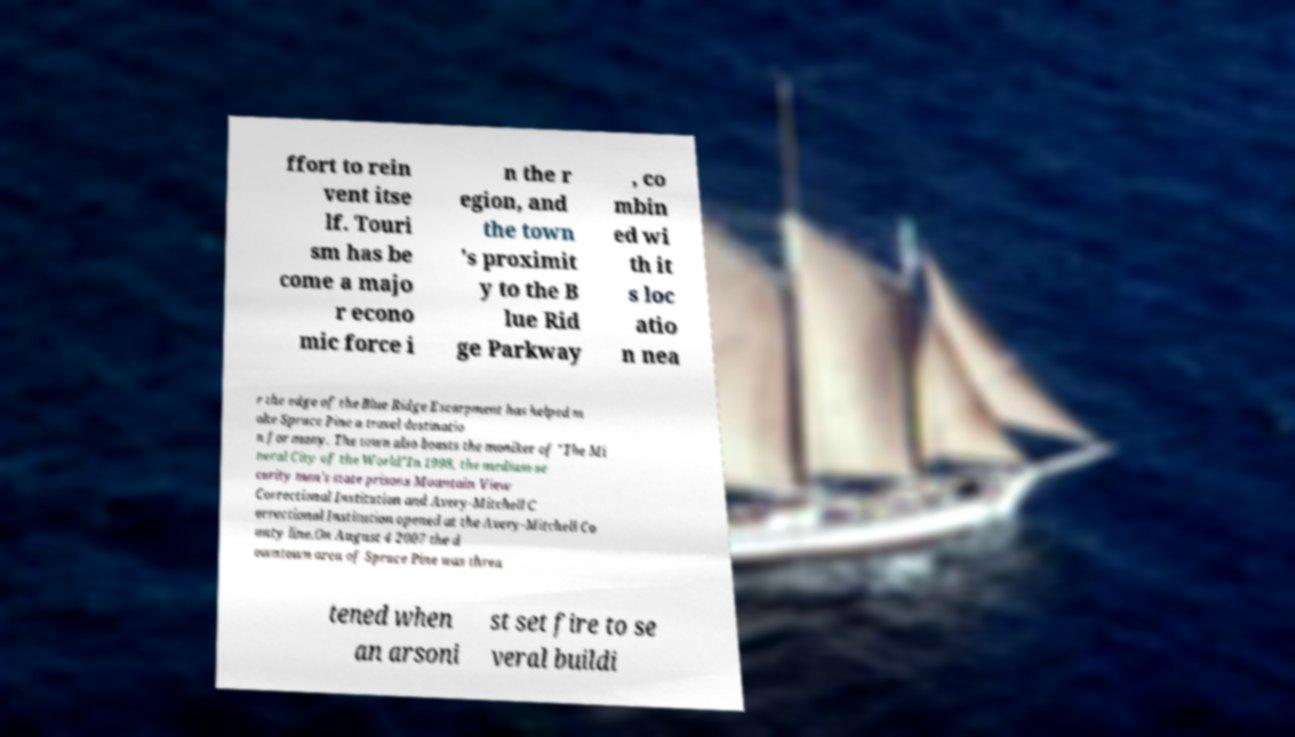Can you accurately transcribe the text from the provided image for me? ffort to rein vent itse lf. Touri sm has be come a majo r econo mic force i n the r egion, and the town 's proximit y to the B lue Rid ge Parkway , co mbin ed wi th it s loc atio n nea r the edge of the Blue Ridge Escarpment has helped m ake Spruce Pine a travel destinatio n for many. The town also boasts the moniker of "The Mi neral City of the World"In 1998, the medium-se curity men's state prisons Mountain View Correctional Institution and Avery-Mitchell C orrectional Institution opened at the Avery-Mitchell Co unty line.On August 4 2007 the d owntown area of Spruce Pine was threa tened when an arsoni st set fire to se veral buildi 